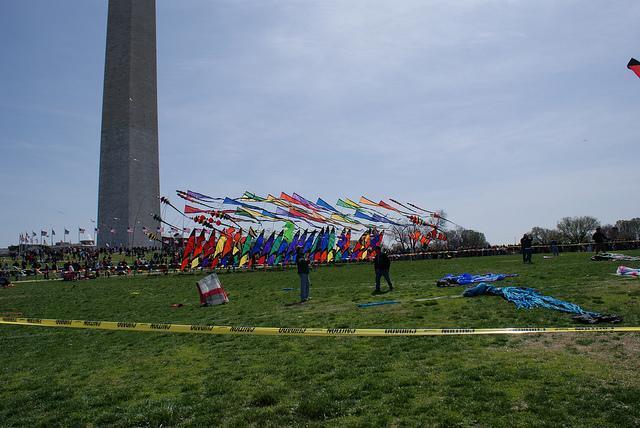How many books are on the sign?
Give a very brief answer. 0. 